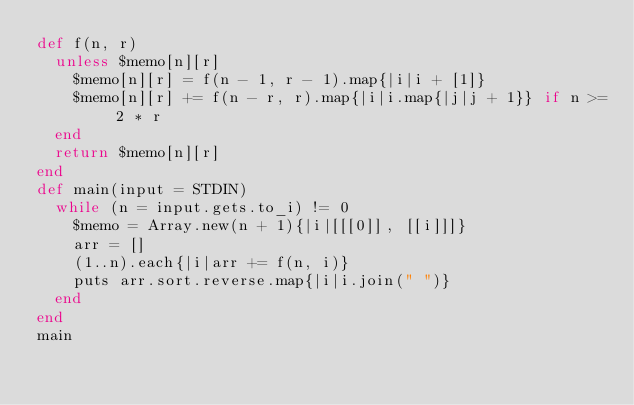<code> <loc_0><loc_0><loc_500><loc_500><_Ruby_>def f(n, r)
  unless $memo[n][r]
    $memo[n][r] = f(n - 1, r - 1).map{|i|i + [1]}
    $memo[n][r] += f(n - r, r).map{|i|i.map{|j|j + 1}} if n >= 2 * r
  end
  return $memo[n][r]
end
def main(input = STDIN)
  while (n = input.gets.to_i) != 0
    $memo = Array.new(n + 1){|i|[[[0]], [[i]]]}
    arr = []
    (1..n).each{|i|arr += f(n, i)}
    puts arr.sort.reverse.map{|i|i.join(" ")}
  end
end
main</code> 